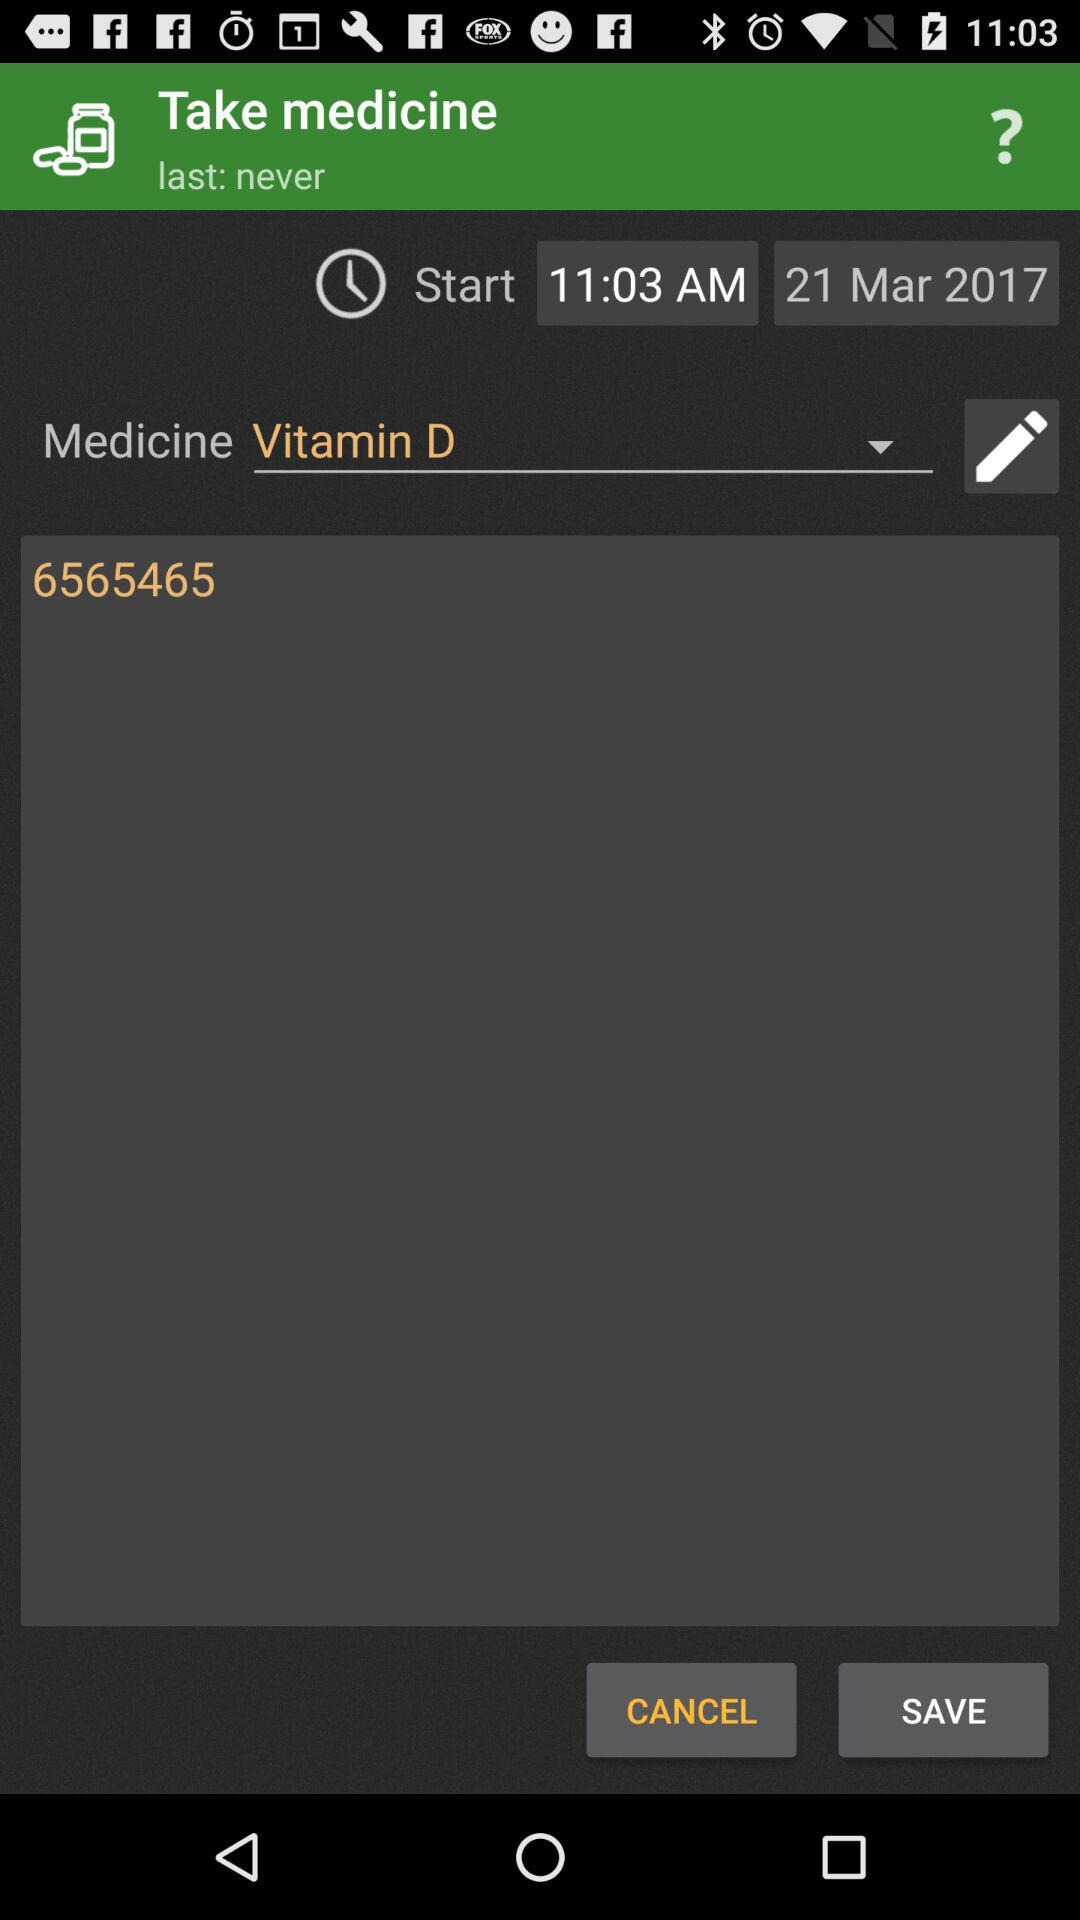What is the start date for taking the medicine? The start date is March 21, 2017. 